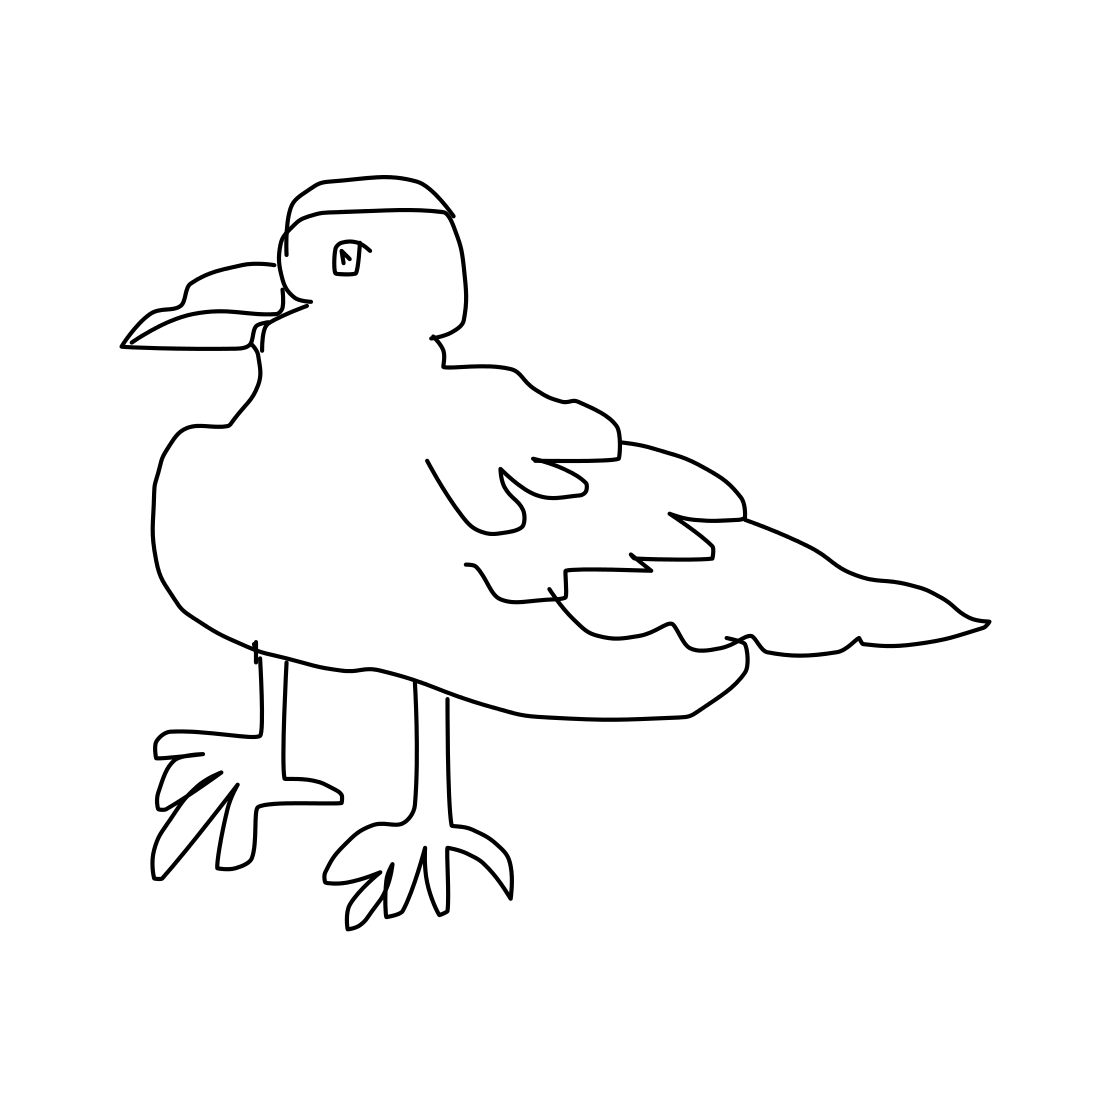In the scene, is a crab in it? No 